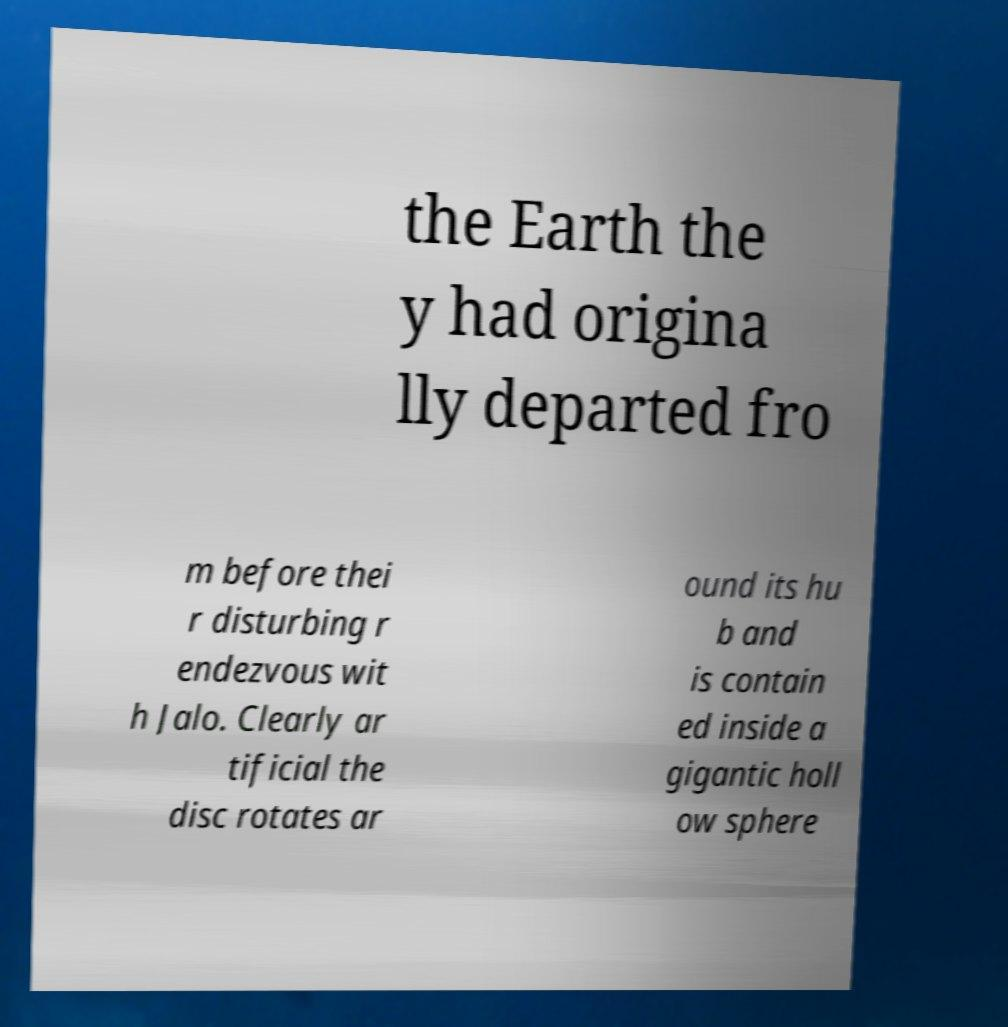Could you extract and type out the text from this image? the Earth the y had origina lly departed fro m before thei r disturbing r endezvous wit h Jalo. Clearly ar tificial the disc rotates ar ound its hu b and is contain ed inside a gigantic holl ow sphere 